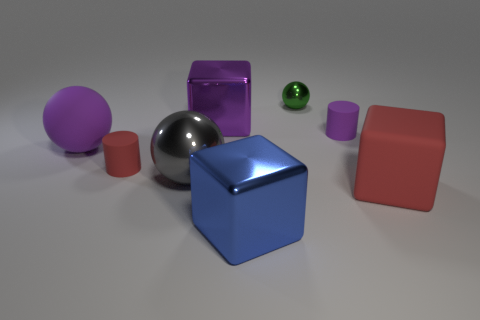Add 1 green spheres. How many objects exist? 9 Subtract all cubes. How many objects are left? 5 Add 8 green spheres. How many green spheres are left? 9 Add 6 matte cylinders. How many matte cylinders exist? 8 Subtract 0 brown spheres. How many objects are left? 8 Subtract all large purple matte spheres. Subtract all big gray metal spheres. How many objects are left? 6 